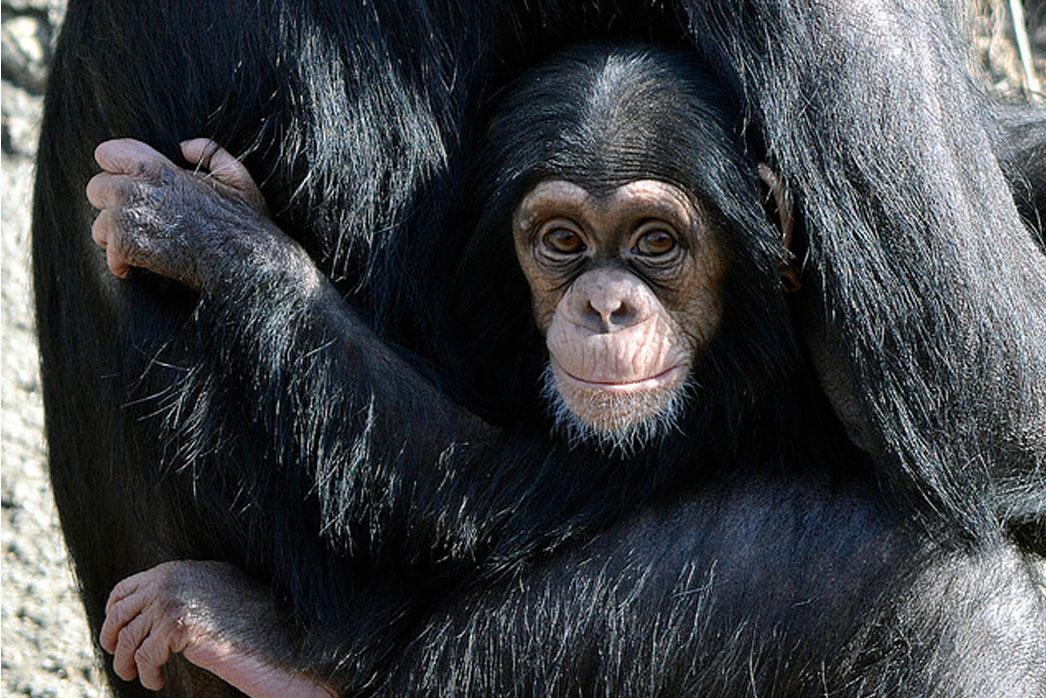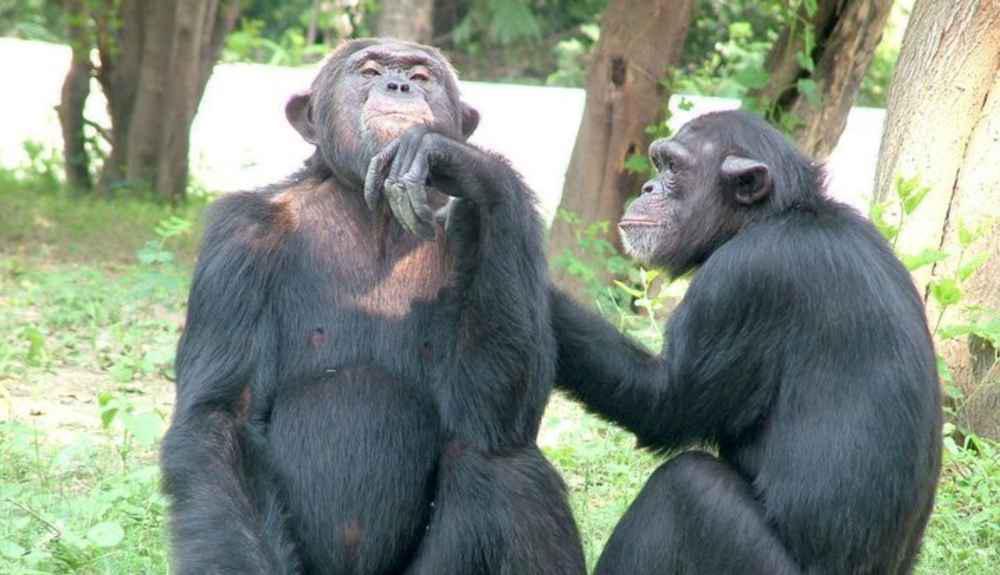The first image is the image on the left, the second image is the image on the right. Assess this claim about the two images: "The image on the left shows a baby monkey clinging on its mother.". Correct or not? Answer yes or no. Yes. The first image is the image on the left, the second image is the image on the right. For the images displayed, is the sentence "Atleast one image shows exactly two chimps sitting in the grass." factually correct? Answer yes or no. Yes. 